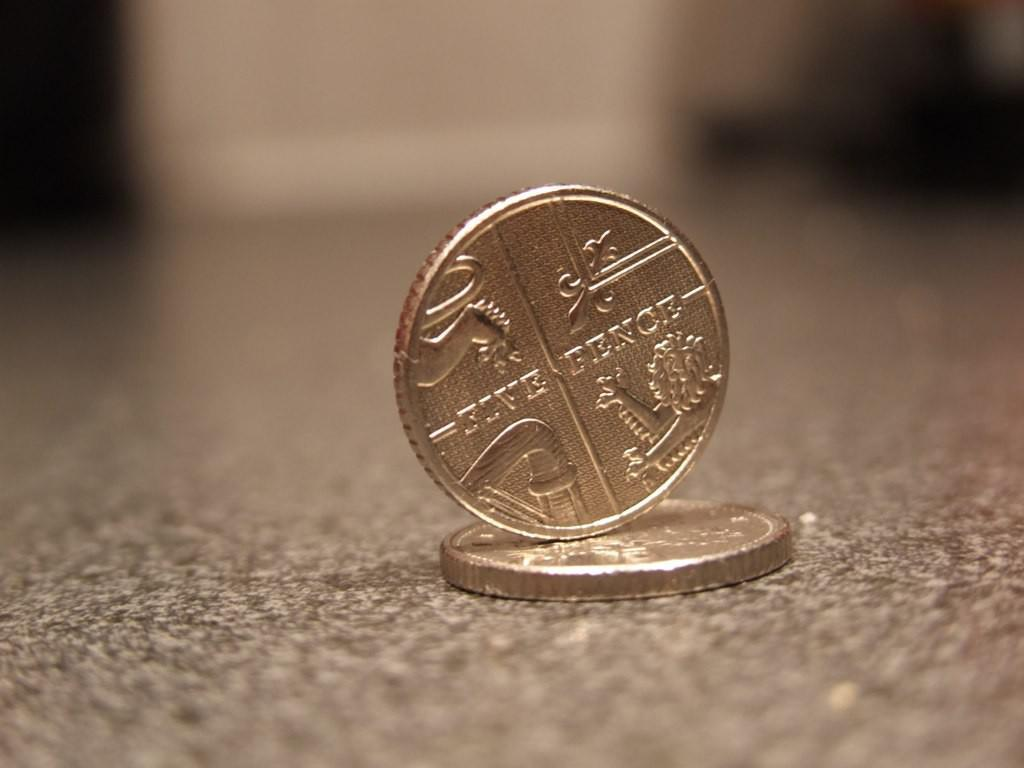<image>
Summarize the visual content of the image. One five pence coin is balancing on another coin 